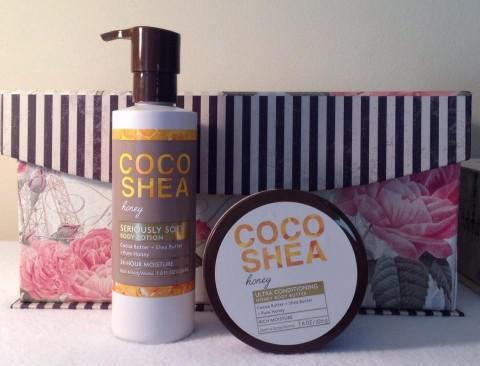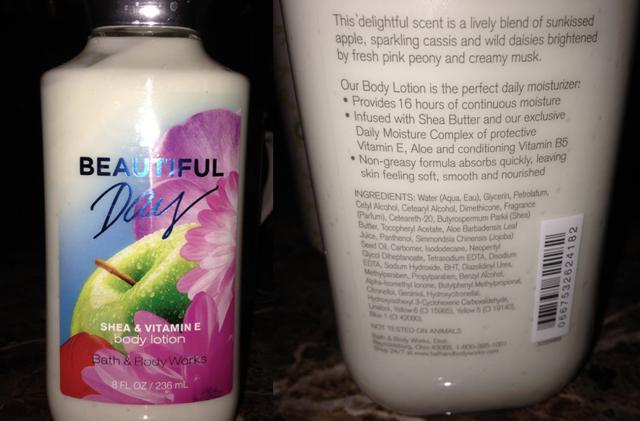The first image is the image on the left, the second image is the image on the right. Assess this claim about the two images: "An image contains at least one horizontal row of five skincare products of the same size and shape.". Correct or not? Answer yes or no. No. The first image is the image on the left, the second image is the image on the right. For the images displayed, is the sentence "There are more than seven bath products." factually correct? Answer yes or no. No. 